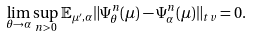<formula> <loc_0><loc_0><loc_500><loc_500>\lim _ { \theta \rightarrow \alpha } \sup _ { n > 0 } { \mathbb { E } } _ { \mu ^ { \prime } , \alpha } \| \Psi ^ { n } _ { \theta } ( \mu ) - \Psi ^ { n } _ { \alpha } ( \mu ) \| _ { t v } = 0 .</formula> 